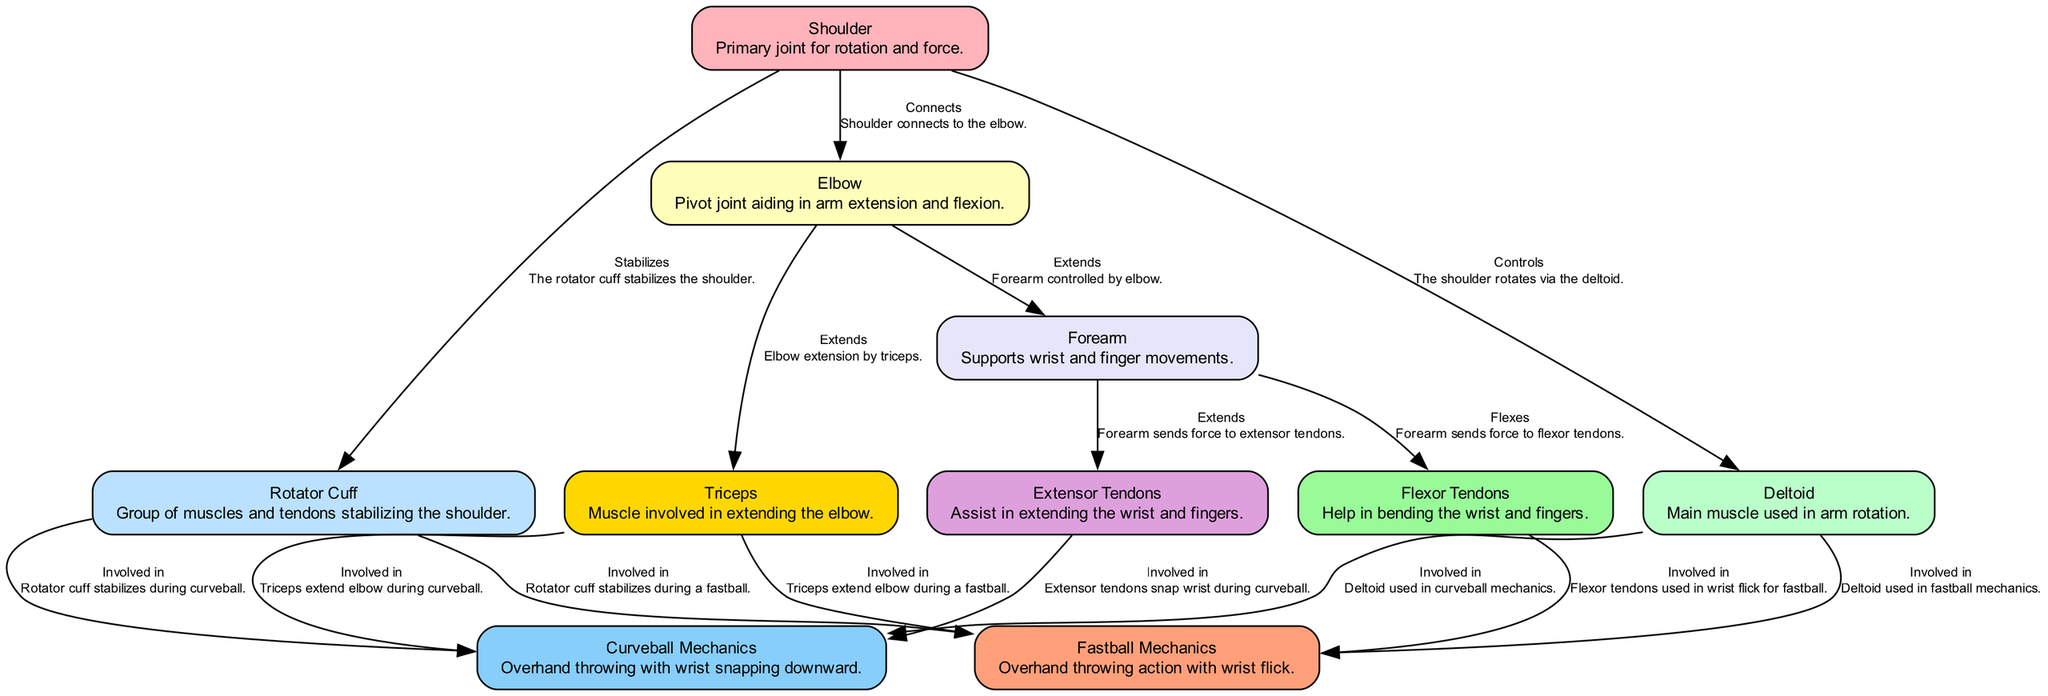What muscle is primarily involved in arm rotation? The diagram labels the Deltoid as the main muscle used in arm rotation, making it the answer to this question.
Answer: Deltoid What joint connects the shoulder and the elbow? According to the diagram, it states that the shoulder connects to the elbow, directly answering the question regarding this connection.
Answer: Elbow How many edges are there in total in the diagram? By counting the connections or relationships shown in the edges between the nodes, there are a total of 12 edges in the diagram.
Answer: 12 What action does the Triceps perform during a fastball? The diagram describes the action of the Triceps as involved in extending the elbow during a fastball, providing the necessary information for the answer.
Answer: Extend Which tendons are used in the wrist flick for a fastball? The diagram explicitly states that the Flexor Tendons are used in the wrist flick for a fastball, thus directly answering the question.
Answer: Flexor Tendons What stabilizes the shoulder during a curveball? The Rotator Cuff is indicated in the diagram as stabilizing the shoulder during a curveball, leading to this concise answer.
Answer: Rotator Cuff How does the Forearm interact with Extensor Tendons? The diagram shows that the Forearm sends force to the Extensor Tendons, which indicates the interaction between them in the pitching mechanics.
Answer: Sends force What is the relationship between the Deltoid and Curveball Mechanics? The diagram explicitly states that the Deltoid is used in curveball mechanics, forming a direct relationship that answers the question.
Answer: Involved in What type of pitching action is described for Fastball Mechanics? The diagram describes Fastball Mechanics as an overhand throwing action characterized by a wrist flick, clearly identifying the type of action involved.
Answer: Overhand throwing action with wrist flick 